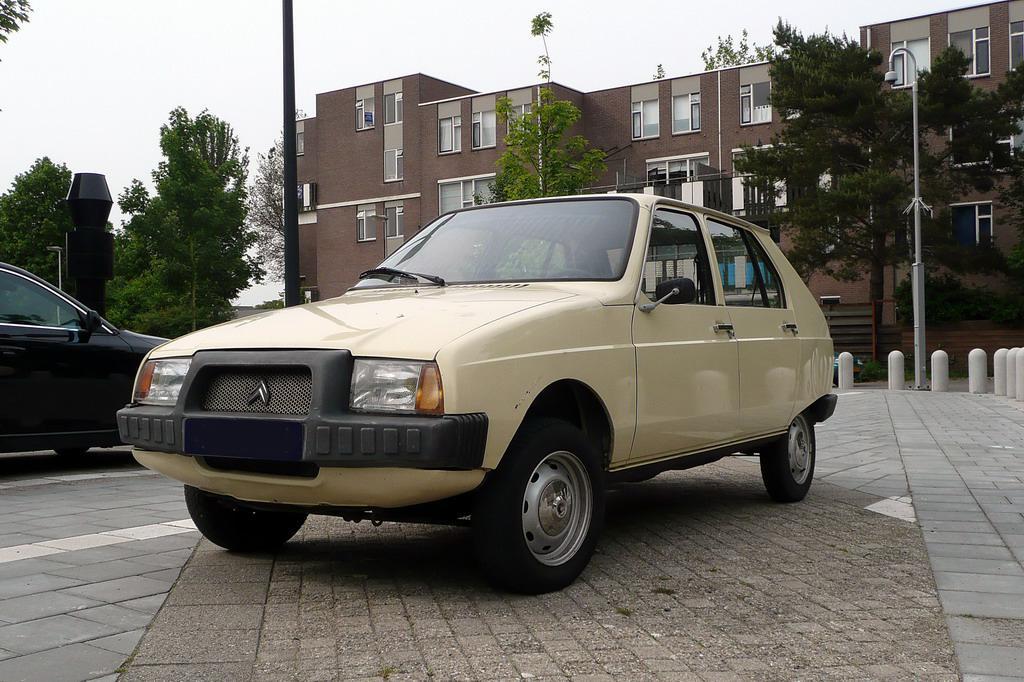How would you summarize this image in a sentence or two? In this picture we can see cars on tiles, poles, light, trees and building. In the background of the image we can see the sky. 